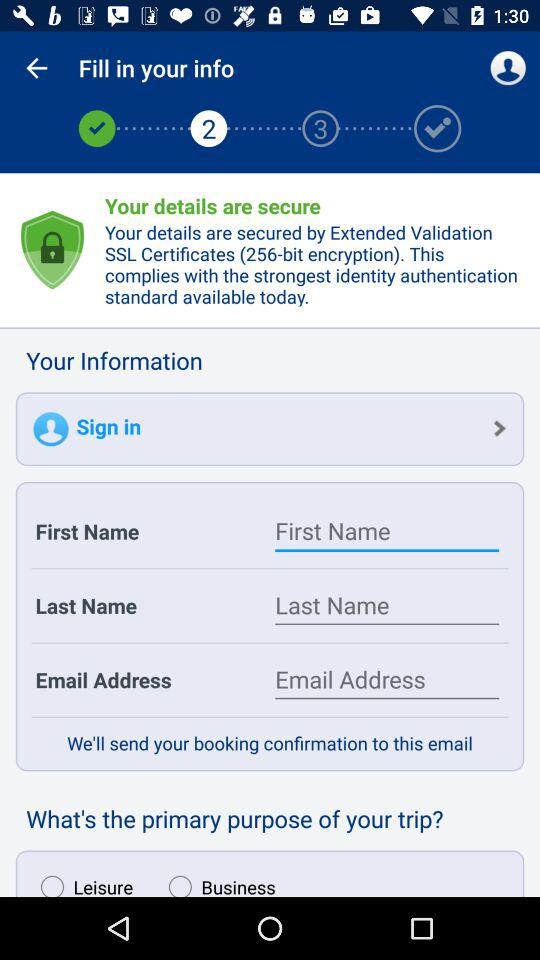Which primary purpose for the trip is selected?
When the provided information is insufficient, respond with <no answer>. <no answer> 